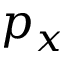Convert formula to latex. <formula><loc_0><loc_0><loc_500><loc_500>p _ { x }</formula> 